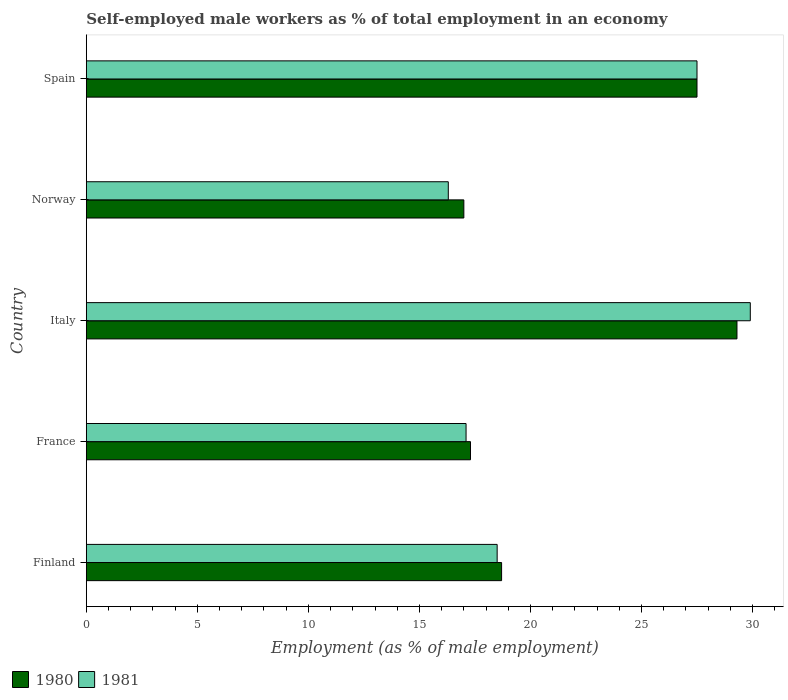How many different coloured bars are there?
Provide a short and direct response. 2. Are the number of bars per tick equal to the number of legend labels?
Offer a very short reply. Yes. Are the number of bars on each tick of the Y-axis equal?
Provide a short and direct response. Yes. How many bars are there on the 1st tick from the top?
Ensure brevity in your answer.  2. How many bars are there on the 2nd tick from the bottom?
Give a very brief answer. 2. What is the label of the 5th group of bars from the top?
Keep it short and to the point. Finland. What is the percentage of self-employed male workers in 1981 in France?
Your response must be concise. 17.1. Across all countries, what is the maximum percentage of self-employed male workers in 1981?
Ensure brevity in your answer.  29.9. Across all countries, what is the minimum percentage of self-employed male workers in 1980?
Your answer should be very brief. 17. In which country was the percentage of self-employed male workers in 1981 minimum?
Give a very brief answer. Norway. What is the total percentage of self-employed male workers in 1980 in the graph?
Offer a very short reply. 109.8. What is the difference between the percentage of self-employed male workers in 1980 in Finland and that in Spain?
Keep it short and to the point. -8.8. What is the difference between the percentage of self-employed male workers in 1980 in Italy and the percentage of self-employed male workers in 1981 in Norway?
Give a very brief answer. 13. What is the average percentage of self-employed male workers in 1981 per country?
Your response must be concise. 21.86. What is the difference between the percentage of self-employed male workers in 1980 and percentage of self-employed male workers in 1981 in France?
Ensure brevity in your answer.  0.2. In how many countries, is the percentage of self-employed male workers in 1980 greater than 14 %?
Give a very brief answer. 5. What is the ratio of the percentage of self-employed male workers in 1981 in Finland to that in Norway?
Make the answer very short. 1.13. Is the difference between the percentage of self-employed male workers in 1980 in France and Italy greater than the difference between the percentage of self-employed male workers in 1981 in France and Italy?
Your answer should be very brief. Yes. What is the difference between the highest and the second highest percentage of self-employed male workers in 1980?
Give a very brief answer. 1.8. What is the difference between the highest and the lowest percentage of self-employed male workers in 1980?
Your answer should be compact. 12.3. What does the 2nd bar from the top in Finland represents?
Ensure brevity in your answer.  1980. How many bars are there?
Your answer should be compact. 10. Are all the bars in the graph horizontal?
Offer a very short reply. Yes. How many countries are there in the graph?
Offer a terse response. 5. Does the graph contain any zero values?
Give a very brief answer. No. Where does the legend appear in the graph?
Make the answer very short. Bottom left. How many legend labels are there?
Provide a succinct answer. 2. How are the legend labels stacked?
Make the answer very short. Horizontal. What is the title of the graph?
Give a very brief answer. Self-employed male workers as % of total employment in an economy. Does "2011" appear as one of the legend labels in the graph?
Ensure brevity in your answer.  No. What is the label or title of the X-axis?
Provide a short and direct response. Employment (as % of male employment). What is the label or title of the Y-axis?
Your answer should be very brief. Country. What is the Employment (as % of male employment) in 1980 in Finland?
Your response must be concise. 18.7. What is the Employment (as % of male employment) in 1980 in France?
Give a very brief answer. 17.3. What is the Employment (as % of male employment) in 1981 in France?
Your response must be concise. 17.1. What is the Employment (as % of male employment) of 1980 in Italy?
Your answer should be compact. 29.3. What is the Employment (as % of male employment) in 1981 in Italy?
Provide a short and direct response. 29.9. What is the Employment (as % of male employment) in 1981 in Norway?
Keep it short and to the point. 16.3. Across all countries, what is the maximum Employment (as % of male employment) of 1980?
Your response must be concise. 29.3. Across all countries, what is the maximum Employment (as % of male employment) in 1981?
Provide a short and direct response. 29.9. Across all countries, what is the minimum Employment (as % of male employment) in 1980?
Make the answer very short. 17. Across all countries, what is the minimum Employment (as % of male employment) of 1981?
Make the answer very short. 16.3. What is the total Employment (as % of male employment) of 1980 in the graph?
Give a very brief answer. 109.8. What is the total Employment (as % of male employment) in 1981 in the graph?
Your response must be concise. 109.3. What is the difference between the Employment (as % of male employment) in 1980 in Finland and that in France?
Your answer should be compact. 1.4. What is the difference between the Employment (as % of male employment) of 1981 in Finland and that in France?
Offer a terse response. 1.4. What is the difference between the Employment (as % of male employment) in 1980 in Finland and that in Norway?
Your answer should be very brief. 1.7. What is the difference between the Employment (as % of male employment) of 1981 in Finland and that in Norway?
Your answer should be very brief. 2.2. What is the difference between the Employment (as % of male employment) of 1980 in Finland and that in Spain?
Give a very brief answer. -8.8. What is the difference between the Employment (as % of male employment) of 1981 in Finland and that in Spain?
Your answer should be very brief. -9. What is the difference between the Employment (as % of male employment) of 1980 in France and that in Italy?
Your answer should be very brief. -12. What is the difference between the Employment (as % of male employment) in 1981 in France and that in Italy?
Give a very brief answer. -12.8. What is the difference between the Employment (as % of male employment) in 1980 in France and that in Norway?
Give a very brief answer. 0.3. What is the difference between the Employment (as % of male employment) in 1980 in France and that in Spain?
Provide a succinct answer. -10.2. What is the difference between the Employment (as % of male employment) in 1981 in Italy and that in Spain?
Keep it short and to the point. 2.4. What is the difference between the Employment (as % of male employment) in 1980 in Norway and that in Spain?
Keep it short and to the point. -10.5. What is the difference between the Employment (as % of male employment) in 1980 in Finland and the Employment (as % of male employment) in 1981 in France?
Offer a terse response. 1.6. What is the difference between the Employment (as % of male employment) in 1980 in Finland and the Employment (as % of male employment) in 1981 in Italy?
Keep it short and to the point. -11.2. What is the difference between the Employment (as % of male employment) of 1980 in Finland and the Employment (as % of male employment) of 1981 in Norway?
Offer a terse response. 2.4. What is the difference between the Employment (as % of male employment) in 1980 in Finland and the Employment (as % of male employment) in 1981 in Spain?
Keep it short and to the point. -8.8. What is the difference between the Employment (as % of male employment) of 1980 in Italy and the Employment (as % of male employment) of 1981 in Spain?
Provide a succinct answer. 1.8. What is the difference between the Employment (as % of male employment) in 1980 in Norway and the Employment (as % of male employment) in 1981 in Spain?
Your answer should be very brief. -10.5. What is the average Employment (as % of male employment) of 1980 per country?
Keep it short and to the point. 21.96. What is the average Employment (as % of male employment) of 1981 per country?
Offer a very short reply. 21.86. What is the difference between the Employment (as % of male employment) of 1980 and Employment (as % of male employment) of 1981 in France?
Keep it short and to the point. 0.2. What is the ratio of the Employment (as % of male employment) of 1980 in Finland to that in France?
Offer a very short reply. 1.08. What is the ratio of the Employment (as % of male employment) of 1981 in Finland to that in France?
Give a very brief answer. 1.08. What is the ratio of the Employment (as % of male employment) in 1980 in Finland to that in Italy?
Your answer should be compact. 0.64. What is the ratio of the Employment (as % of male employment) in 1981 in Finland to that in Italy?
Your answer should be very brief. 0.62. What is the ratio of the Employment (as % of male employment) of 1981 in Finland to that in Norway?
Offer a terse response. 1.14. What is the ratio of the Employment (as % of male employment) in 1980 in Finland to that in Spain?
Your response must be concise. 0.68. What is the ratio of the Employment (as % of male employment) of 1981 in Finland to that in Spain?
Offer a terse response. 0.67. What is the ratio of the Employment (as % of male employment) in 1980 in France to that in Italy?
Your response must be concise. 0.59. What is the ratio of the Employment (as % of male employment) of 1981 in France to that in Italy?
Keep it short and to the point. 0.57. What is the ratio of the Employment (as % of male employment) of 1980 in France to that in Norway?
Ensure brevity in your answer.  1.02. What is the ratio of the Employment (as % of male employment) in 1981 in France to that in Norway?
Your response must be concise. 1.05. What is the ratio of the Employment (as % of male employment) of 1980 in France to that in Spain?
Make the answer very short. 0.63. What is the ratio of the Employment (as % of male employment) in 1981 in France to that in Spain?
Your response must be concise. 0.62. What is the ratio of the Employment (as % of male employment) of 1980 in Italy to that in Norway?
Keep it short and to the point. 1.72. What is the ratio of the Employment (as % of male employment) in 1981 in Italy to that in Norway?
Your answer should be very brief. 1.83. What is the ratio of the Employment (as % of male employment) in 1980 in Italy to that in Spain?
Provide a short and direct response. 1.07. What is the ratio of the Employment (as % of male employment) in 1981 in Italy to that in Spain?
Ensure brevity in your answer.  1.09. What is the ratio of the Employment (as % of male employment) in 1980 in Norway to that in Spain?
Provide a succinct answer. 0.62. What is the ratio of the Employment (as % of male employment) in 1981 in Norway to that in Spain?
Make the answer very short. 0.59. What is the difference between the highest and the second highest Employment (as % of male employment) in 1980?
Your response must be concise. 1.8. What is the difference between the highest and the second highest Employment (as % of male employment) in 1981?
Your response must be concise. 2.4. What is the difference between the highest and the lowest Employment (as % of male employment) in 1980?
Ensure brevity in your answer.  12.3. What is the difference between the highest and the lowest Employment (as % of male employment) in 1981?
Keep it short and to the point. 13.6. 